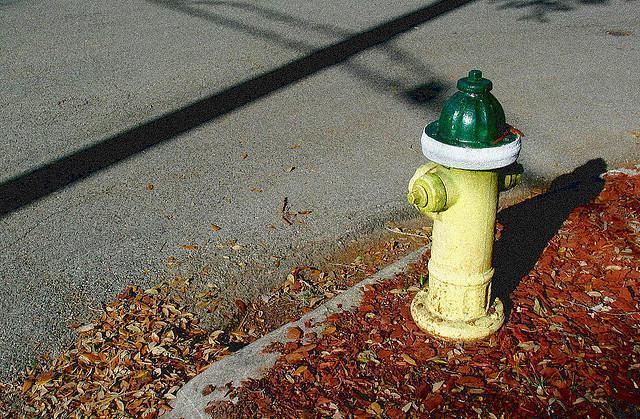How many hoses are attached to the hydrant?
Give a very brief answer. 0. 